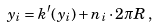Convert formula to latex. <formula><loc_0><loc_0><loc_500><loc_500>y _ { i } = k ^ { \prime } ( y _ { i } ) + n _ { i } \cdot 2 \pi R \, ,</formula> 